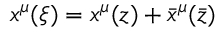Convert formula to latex. <formula><loc_0><loc_0><loc_500><loc_500>x ^ { \mu } ( \xi ) = x ^ { \mu } ( z ) + \bar { x } ^ { \mu } ( { \bar { z } } )</formula> 